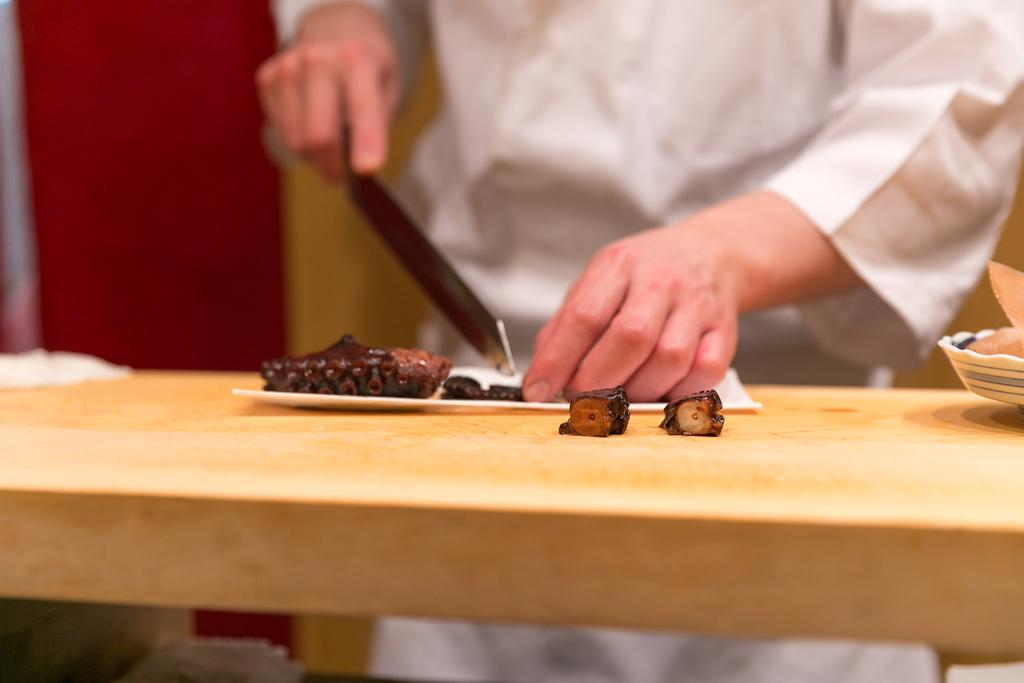What is present in the image that is related to cooking or food preparation? There are food items in the image, and they are being chopped by a chef. What is the chef doing with the food items? The chef is chopping the food items. What type of pie is being served as a joke in the image? There is no pie present in the image, nor is there any indication of humor or jokes. 